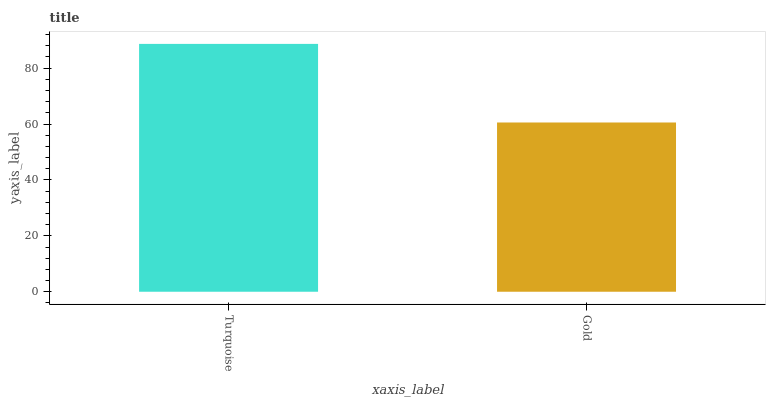Is Gold the minimum?
Answer yes or no. Yes. Is Turquoise the maximum?
Answer yes or no. Yes. Is Gold the maximum?
Answer yes or no. No. Is Turquoise greater than Gold?
Answer yes or no. Yes. Is Gold less than Turquoise?
Answer yes or no. Yes. Is Gold greater than Turquoise?
Answer yes or no. No. Is Turquoise less than Gold?
Answer yes or no. No. Is Turquoise the high median?
Answer yes or no. Yes. Is Gold the low median?
Answer yes or no. Yes. Is Gold the high median?
Answer yes or no. No. Is Turquoise the low median?
Answer yes or no. No. 